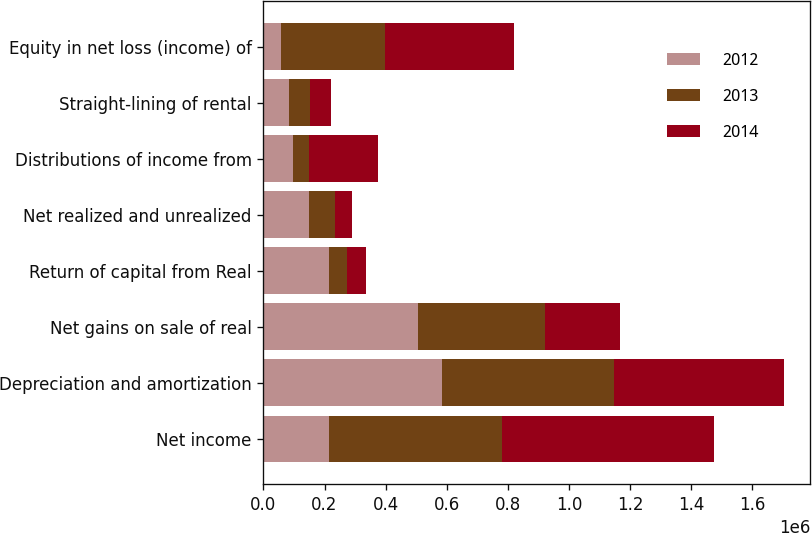<chart> <loc_0><loc_0><loc_500><loc_500><stacked_bar_chart><ecel><fcel>Net income<fcel>Depreciation and amortization<fcel>Net gains on sale of real<fcel>Return of capital from Real<fcel>Net realized and unrealized<fcel>Distributions of income from<fcel>Straight-lining of rental<fcel>Equity in net loss (income) of<nl><fcel>2012<fcel>215676<fcel>583408<fcel>507192<fcel>215676<fcel>150139<fcel>96286<fcel>82800<fcel>58131<nl><fcel>2013<fcel>564740<fcel>561998<fcel>414502<fcel>56664<fcel>85771<fcel>54030<fcel>69391<fcel>338785<nl><fcel>2014<fcel>694541<fcel>557888<fcel>245799<fcel>63762<fcel>55361<fcel>226172<fcel>69648<fcel>423126<nl></chart> 